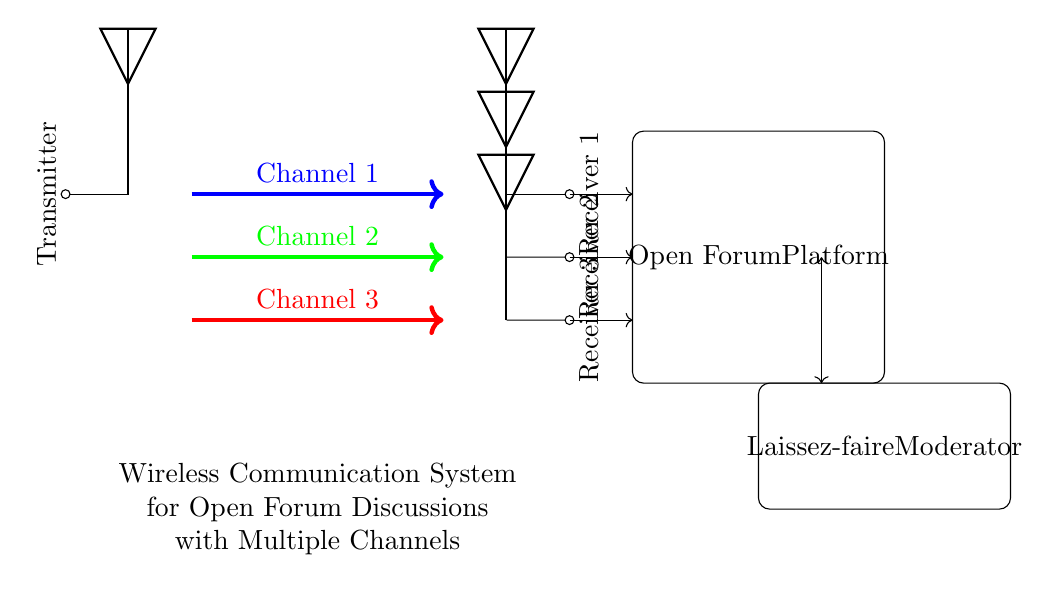What is the number of channels in this system? The circuit diagram shows three distinct wireless channels indicated by different colors: blue, green, and red. Therefore, counting these channels provides the answer.
Answer: 3 What do the antennas represent in this circuit? The antennas represent the transmitter and receivers in this wireless communication system. The diagram clearly labels one antenna as the transmitter on the left and three antennas as receivers on the right.
Answer: Transmitter and Receivers Which component is responsible for moderation in this system? The circuit includes a labeled box at the bottom right stating "Laissez-faire Moderator." This indicates that the moderation role is embodied in the corresponding component of the circuit.
Answer: Laissez-faire Moderator What is the function of the arrows in the channels? The arrows indicate the direction of communication between the transmitter and the receivers through the channels. Each arrow flows from the transmitter to each of the receivers along the channels, demonstrating the flow of information.
Answer: Direction of communication How many receivers are connected to the transmitter? The transmitter connects to three different receivers as indicated by the circuit's layout, where each receiver receives a separate channel signal from the transmitter. Count the antennas on the right side to verify this.
Answer: 3 What type of communication does this system facilitate? The diagram and system description indicate that this is a wireless communication system designed for open forum discussions, highlighting its purpose as facilitating discussion rather than private communication.
Answer: Open forum discussions 